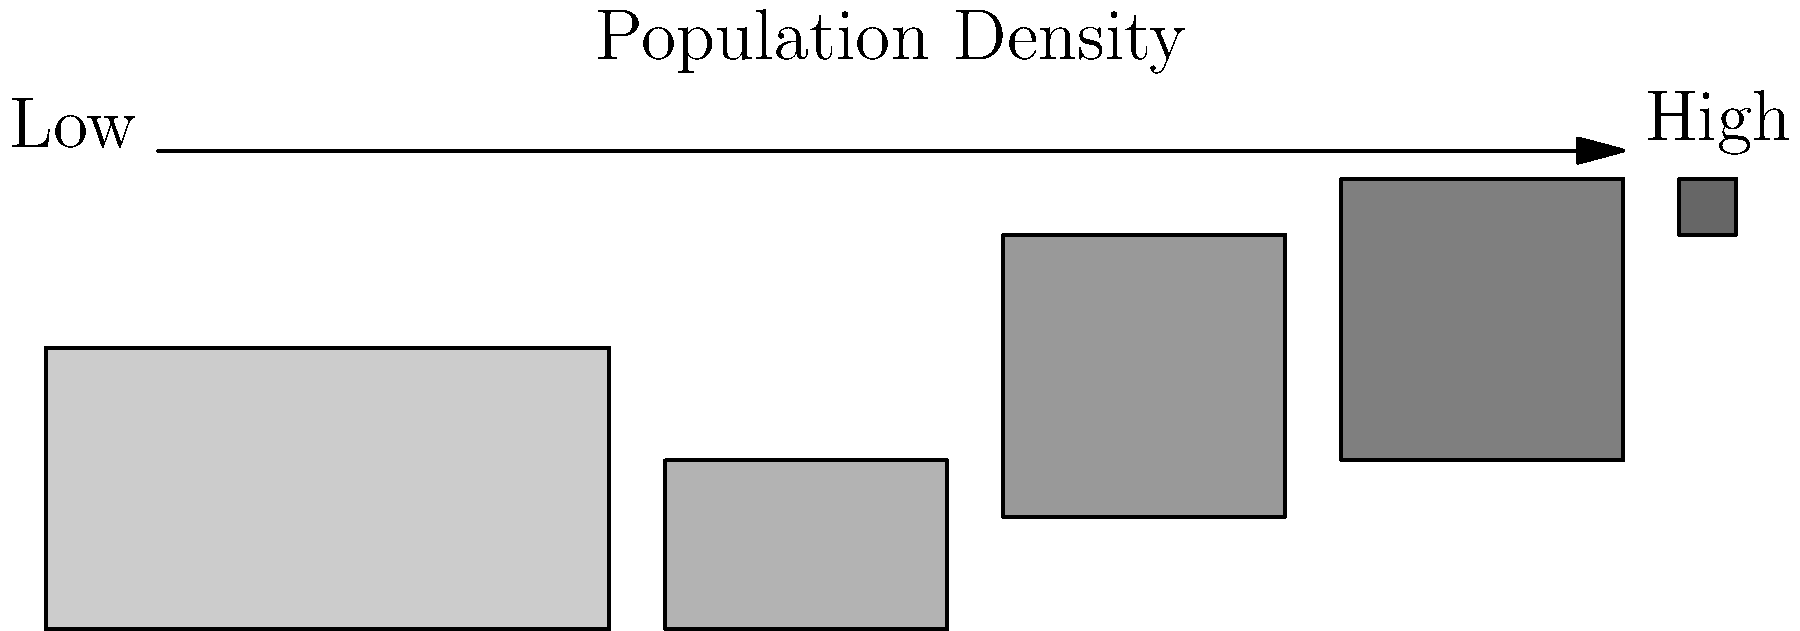As a social worker aiming to understand global population distribution, what cultural and socioeconomic factors might contribute to the higher population density observed in Eastern Asia compared to other regions of the world? To answer this question, we need to consider several factors that contribute to population density in Eastern Asia:

1. Historical factors:
   - Long history of agricultural civilization
   - Early development of complex societies and empires

2. Geographical factors:
   - Fertile river valleys (e.g., Yellow River, Yangtze River)
   - Favorable climate for agriculture

3. Cultural factors:
   - Traditional emphasis on family and childbearing
   - Cultural values that prioritize collective well-being

4. Economic factors:
   - Rapid industrialization and urbanization in the 20th and 21st centuries
   - Economic policies promoting population growth

5. Political factors:
   - Historical population policies (e.g., China's former one-child policy and its reversal)

6. Technological advancements:
   - Improved agricultural techniques leading to higher food production
   - Better healthcare and increased life expectancy

7. Limited outward migration:
   - Historical isolation and limited opportunities for large-scale emigration

8. Urban concentration:
   - Development of megacities and urban agglomerations

Understanding these factors is crucial for a social worker to comprehend the cultural context and socioeconomic challenges faced by populations in densely populated regions. This knowledge can inform approaches to social services, community development, and cultural sensitivity in working with diverse populations.
Answer: Historical agricultural development, cultural values, rapid industrialization, and geographical advantages have contributed to higher population density in Eastern Asia. 